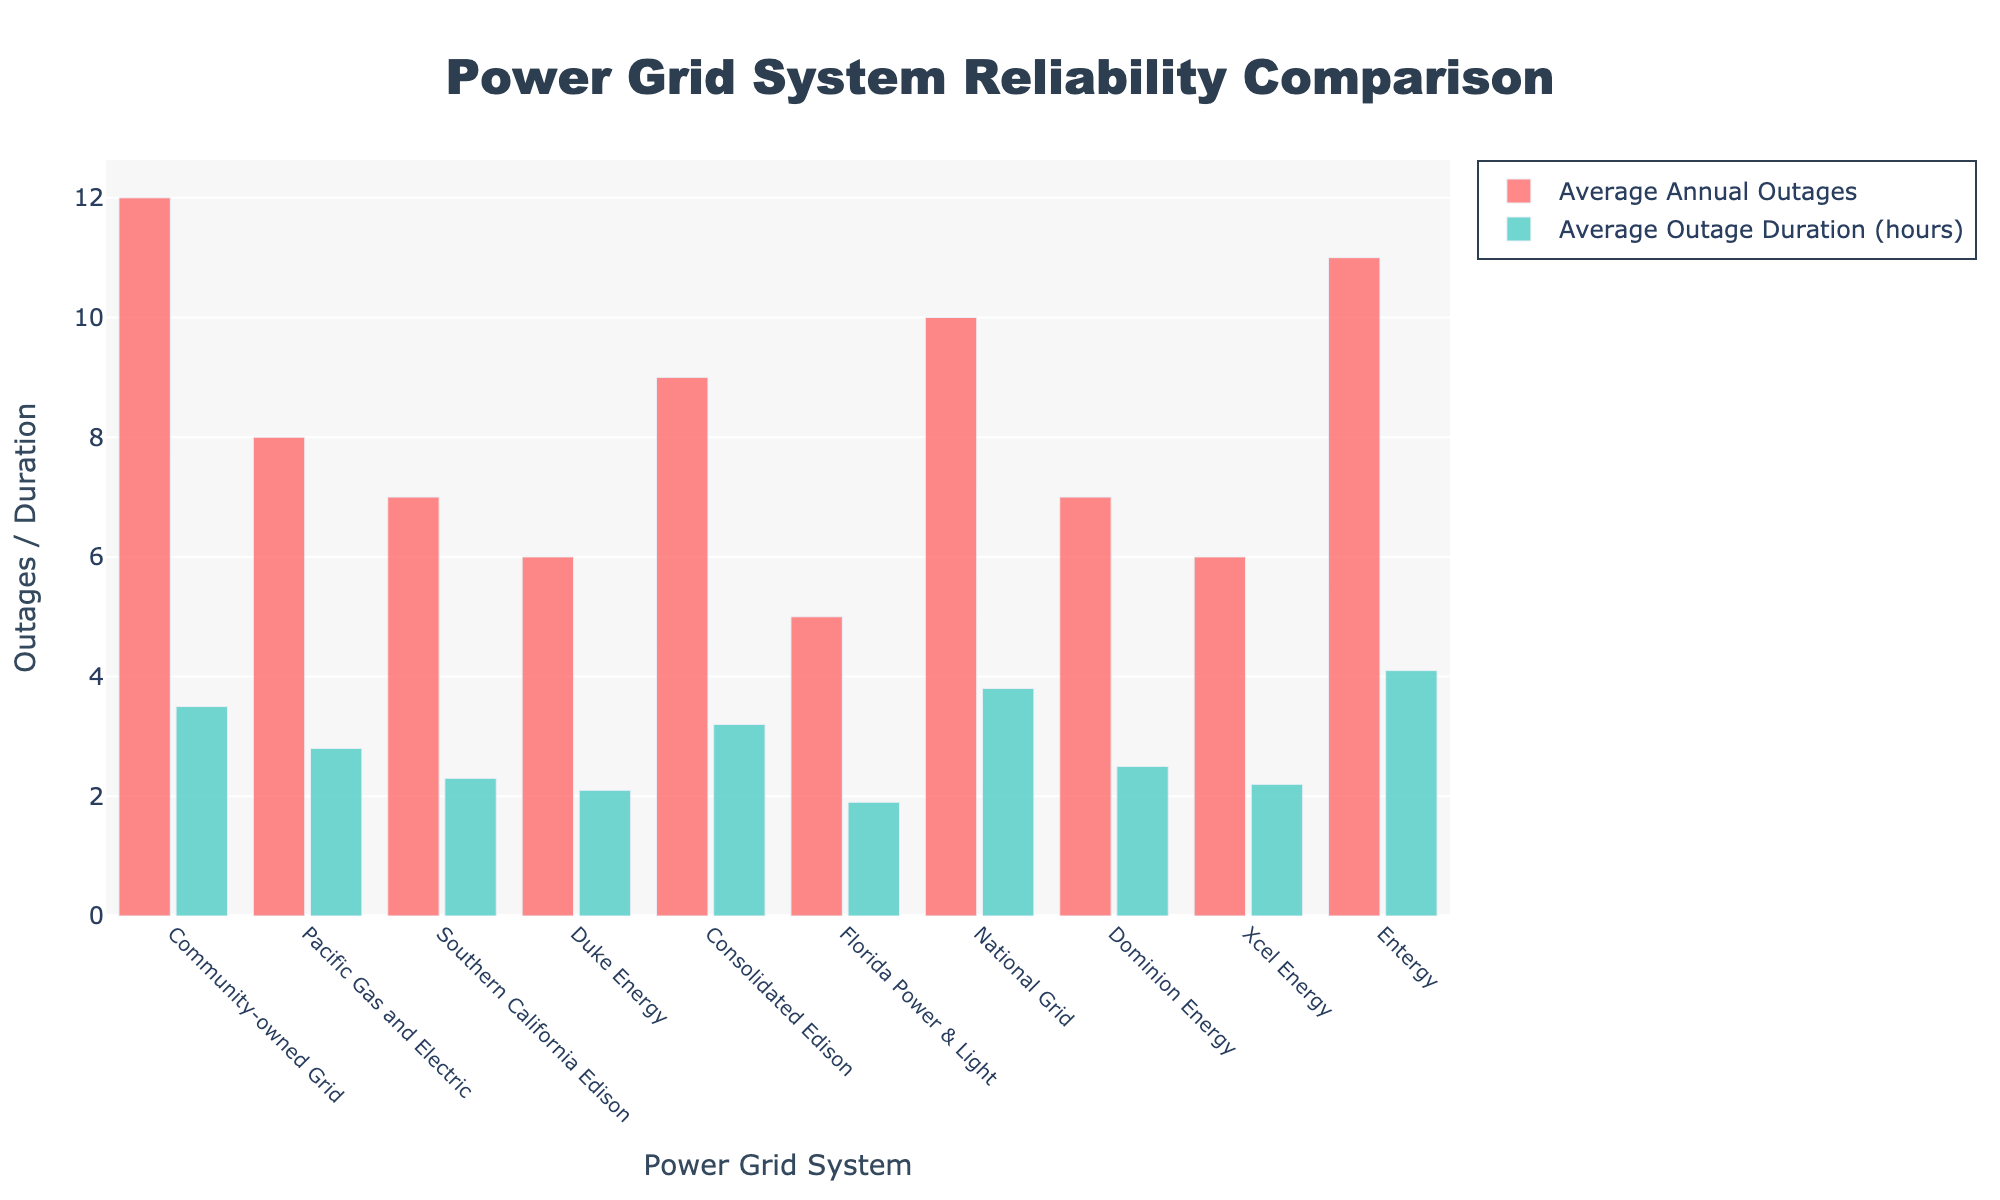Which power grid system has the highest average annual outages? Observe the heights of the bars representing 'Average Annual Outages' for each power grid system. The highest bar corresponds to Entergy with 11 average annual outages.
Answer: Entergy Which power grid system has the longest average outage duration? Look at the bars colored in green, representing 'Average Outage Duration (hours)'. The tallest bar is for Entergy with an average outage duration of 4.1 hours.
Answer: Entergy How does the community-owned grid compare in terms of outages to Florida Power & Light? Compare the heights of the red bars for 'Average Annual Outages' between the two grids. The community-owned grid has 12 outages, while Florida Power & Light has 5 outages.
Answer: The community-owned grid has more outages What is the difference in average annual outages between the community-owned grid and Duke Energy? Calculate the difference between the community-owned grid's 12 outages and Duke Energy's 6 outages: 12 - 6 = 6.
Answer: 6 Which power grids have an average outage duration of less than 2.5 hours? Identify the green bars shorter than the 2.5-hour mark. Pacific Gas and Electric (2.8), Southern California Edison (2.3), Duke Energy (2.1), Florida Power & Light (1.9), and Xcel Energy (2.2) fit this criterion.
Answer: Pacific Gas and Electric, Southern California Edison, Duke Energy, Florida Power & Light, Xcel Energy What is the combined average outage duration for Southern California Edison and Dominion Energy? Sum the average outage durations for these two grids: 2.3 (Southern California Edison) + 2.5 (Dominion Energy) = 4.8 hours.
Answer: 4.8 hours Is the average outage duration of the community-owned grid higher or lower than that of National Grid? Compare the heights of the green bars for both grids. The community-owned grid has a duration of 3.5 hours, while National Grid has a duration of 3.8 hours, making the community-owned grid's duration lower.
Answer: Lower What is the average annual outage for all power grids combined? Calculate the mean by summing all the average annual outages and dividing by the number of grids: (12+8+7+6+9+5+10+7+6+11) / 10 = 81 / 10 = 8.1.
Answer: 8.1 What is the ratio of average annual outages to average outage duration for Florida Power & Light? Divide the average annual outages (5) by the average outage duration (1.9) to obtain the ratio: 5 / 1.9 ≈ 2.63.
Answer: 2.63 Which power grid has fewer annual outages but longer outage duration compared to Consolidated Edison? Identify the grid with fewer than 9 annual outages and an outage duration more than 3.2 hours. Entergy fits this criterion with 11 outages but an outage duration of 4.1 hours.
Answer: Entergy 